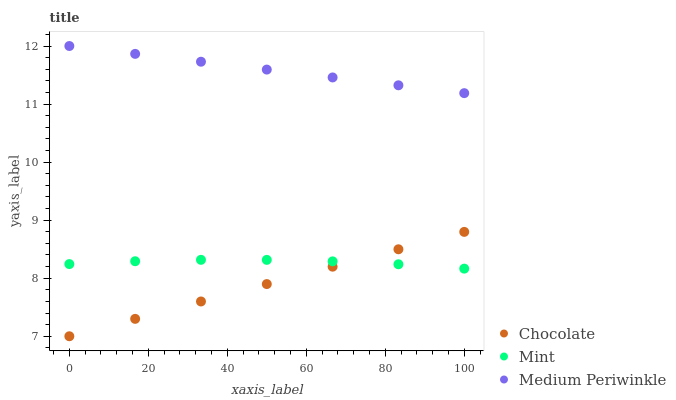Does Chocolate have the minimum area under the curve?
Answer yes or no. Yes. Does Medium Periwinkle have the maximum area under the curve?
Answer yes or no. Yes. Does Mint have the minimum area under the curve?
Answer yes or no. No. Does Mint have the maximum area under the curve?
Answer yes or no. No. Is Chocolate the smoothest?
Answer yes or no. Yes. Is Mint the roughest?
Answer yes or no. Yes. Is Mint the smoothest?
Answer yes or no. No. Is Chocolate the roughest?
Answer yes or no. No. Does Chocolate have the lowest value?
Answer yes or no. Yes. Does Mint have the lowest value?
Answer yes or no. No. Does Medium Periwinkle have the highest value?
Answer yes or no. Yes. Does Chocolate have the highest value?
Answer yes or no. No. Is Chocolate less than Medium Periwinkle?
Answer yes or no. Yes. Is Medium Periwinkle greater than Chocolate?
Answer yes or no. Yes. Does Mint intersect Chocolate?
Answer yes or no. Yes. Is Mint less than Chocolate?
Answer yes or no. No. Is Mint greater than Chocolate?
Answer yes or no. No. Does Chocolate intersect Medium Periwinkle?
Answer yes or no. No. 